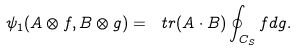<formula> <loc_0><loc_0><loc_500><loc_500>\psi _ { 1 } ( A \otimes f , B \otimes g ) = \ t r ( A \cdot B ) \oint _ { C _ { S } } f d g .</formula> 